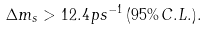Convert formula to latex. <formula><loc_0><loc_0><loc_500><loc_500>\Delta m _ { s } > 1 2 . 4 \, p s ^ { - 1 } \, ( 9 5 \% \, C . L . ) .</formula> 